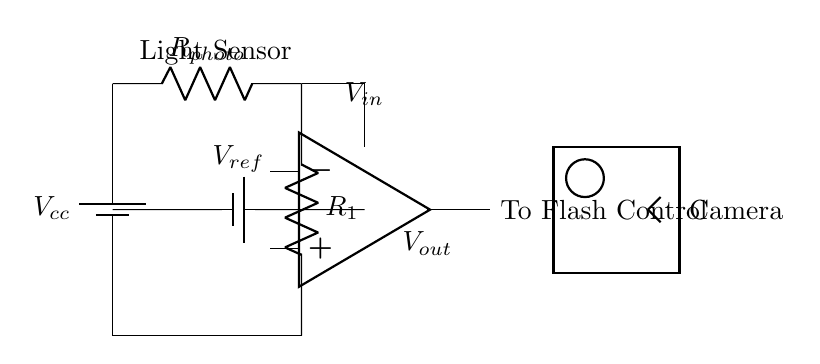What is the purpose of the photoresistor? The photoresistor is used as a light sensor that detects ambient light levels. In low light conditions, its resistance decreases, allowing more current to flow through the circuit and enabling the flash control.
Answer: Light sensor What is the role of the comparator in this circuit? The comparator compares the voltage from the photoresistor and the reference voltage to determine whether to activate the flash. If the input voltage from the sensor is lower than the reference, the comparator outputs a signal to trigger the flash.
Answer: Comparator What are the values of the resistors in this circuit? The circuit features two resistors: one is the photoresistor and the other is the fixed resistor R1, but their actual resistance values are not provided in the diagram.
Answer: Not specified What is the reference voltage denoted as in the circuit? The reference voltage is denoted as V ref in the circuit diagram, which is connected to one of the inputs of the comparator.
Answer: V ref How does the light level influence the output voltage? When light levels are low, the resistance of the photoresistor drops, increasing the input voltage to the comparator. If this voltage is lower than V ref, the output changes state to trigger the flash.
Answer: It increases input voltage What type of circuit is this? This is an analog circuit designed for automatic camera flash control based on varying lighting conditions.
Answer: Analog circuit What is connected to the output of the comparator? The output of the comparator is connected to the flash control system, which activates the flash based on the comparator's output signal.
Answer: To Flash Control 